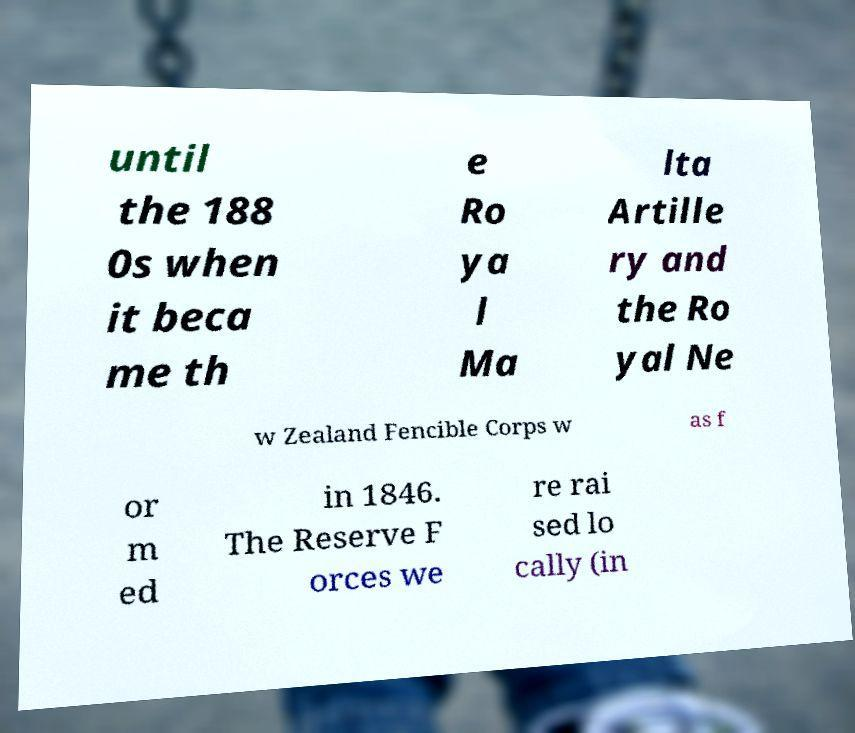For documentation purposes, I need the text within this image transcribed. Could you provide that? until the 188 0s when it beca me th e Ro ya l Ma lta Artille ry and the Ro yal Ne w Zealand Fencible Corps w as f or m ed in 1846. The Reserve F orces we re rai sed lo cally (in 